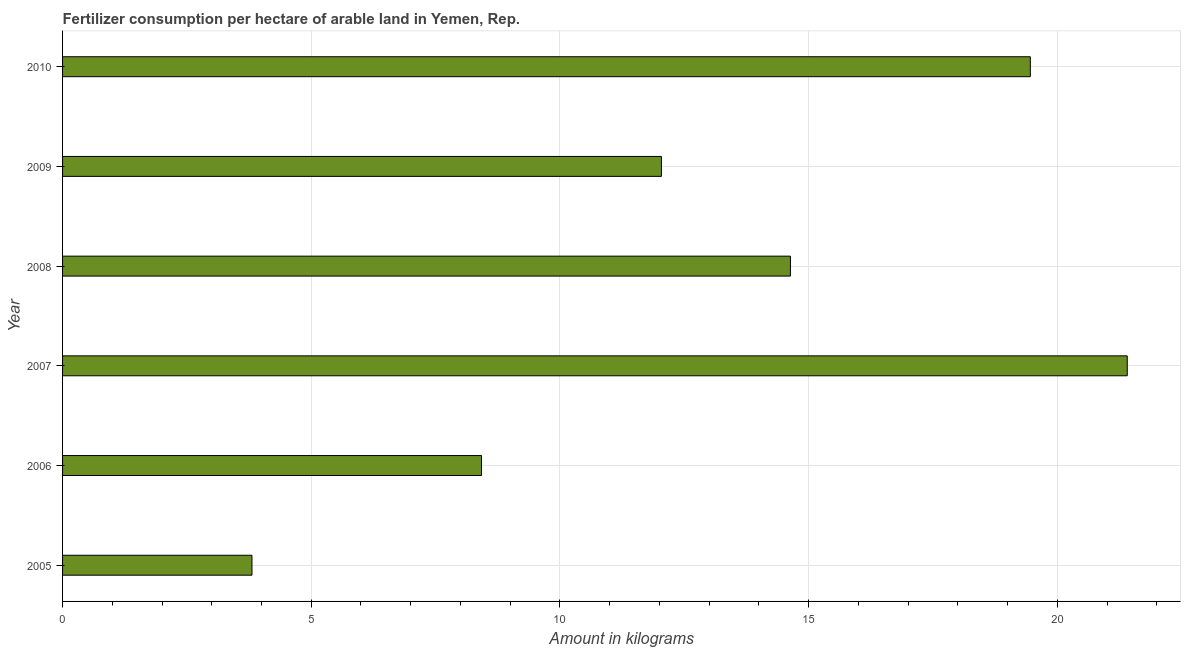Does the graph contain any zero values?
Provide a succinct answer. No. What is the title of the graph?
Ensure brevity in your answer.  Fertilizer consumption per hectare of arable land in Yemen, Rep. . What is the label or title of the X-axis?
Keep it short and to the point. Amount in kilograms. What is the amount of fertilizer consumption in 2007?
Keep it short and to the point. 21.41. Across all years, what is the maximum amount of fertilizer consumption?
Offer a very short reply. 21.41. Across all years, what is the minimum amount of fertilizer consumption?
Your answer should be compact. 3.81. What is the sum of the amount of fertilizer consumption?
Make the answer very short. 79.77. What is the difference between the amount of fertilizer consumption in 2006 and 2007?
Offer a very short reply. -12.98. What is the average amount of fertilizer consumption per year?
Your answer should be compact. 13.29. What is the median amount of fertilizer consumption?
Ensure brevity in your answer.  13.34. What is the ratio of the amount of fertilizer consumption in 2005 to that in 2007?
Offer a terse response. 0.18. Is the difference between the amount of fertilizer consumption in 2006 and 2010 greater than the difference between any two years?
Give a very brief answer. No. What is the difference between the highest and the second highest amount of fertilizer consumption?
Offer a very short reply. 1.95. In how many years, is the amount of fertilizer consumption greater than the average amount of fertilizer consumption taken over all years?
Provide a short and direct response. 3. How many bars are there?
Offer a very short reply. 6. What is the difference between two consecutive major ticks on the X-axis?
Provide a succinct answer. 5. What is the Amount in kilograms in 2005?
Provide a succinct answer. 3.81. What is the Amount in kilograms of 2006?
Make the answer very short. 8.42. What is the Amount in kilograms in 2007?
Your answer should be compact. 21.41. What is the Amount in kilograms in 2008?
Make the answer very short. 14.63. What is the Amount in kilograms in 2009?
Ensure brevity in your answer.  12.04. What is the Amount in kilograms of 2010?
Your response must be concise. 19.46. What is the difference between the Amount in kilograms in 2005 and 2006?
Your answer should be compact. -4.62. What is the difference between the Amount in kilograms in 2005 and 2007?
Provide a succinct answer. -17.6. What is the difference between the Amount in kilograms in 2005 and 2008?
Give a very brief answer. -10.83. What is the difference between the Amount in kilograms in 2005 and 2009?
Ensure brevity in your answer.  -8.23. What is the difference between the Amount in kilograms in 2005 and 2010?
Offer a very short reply. -15.65. What is the difference between the Amount in kilograms in 2006 and 2007?
Provide a succinct answer. -12.98. What is the difference between the Amount in kilograms in 2006 and 2008?
Offer a very short reply. -6.21. What is the difference between the Amount in kilograms in 2006 and 2009?
Offer a very short reply. -3.62. What is the difference between the Amount in kilograms in 2006 and 2010?
Your answer should be very brief. -11.03. What is the difference between the Amount in kilograms in 2007 and 2008?
Your answer should be compact. 6.77. What is the difference between the Amount in kilograms in 2007 and 2009?
Your answer should be compact. 9.37. What is the difference between the Amount in kilograms in 2007 and 2010?
Ensure brevity in your answer.  1.95. What is the difference between the Amount in kilograms in 2008 and 2009?
Provide a succinct answer. 2.59. What is the difference between the Amount in kilograms in 2008 and 2010?
Ensure brevity in your answer.  -4.82. What is the difference between the Amount in kilograms in 2009 and 2010?
Your answer should be compact. -7.42. What is the ratio of the Amount in kilograms in 2005 to that in 2006?
Offer a very short reply. 0.45. What is the ratio of the Amount in kilograms in 2005 to that in 2007?
Provide a short and direct response. 0.18. What is the ratio of the Amount in kilograms in 2005 to that in 2008?
Provide a short and direct response. 0.26. What is the ratio of the Amount in kilograms in 2005 to that in 2009?
Provide a succinct answer. 0.32. What is the ratio of the Amount in kilograms in 2005 to that in 2010?
Provide a succinct answer. 0.2. What is the ratio of the Amount in kilograms in 2006 to that in 2007?
Your response must be concise. 0.39. What is the ratio of the Amount in kilograms in 2006 to that in 2008?
Provide a succinct answer. 0.58. What is the ratio of the Amount in kilograms in 2006 to that in 2010?
Keep it short and to the point. 0.43. What is the ratio of the Amount in kilograms in 2007 to that in 2008?
Provide a short and direct response. 1.46. What is the ratio of the Amount in kilograms in 2007 to that in 2009?
Keep it short and to the point. 1.78. What is the ratio of the Amount in kilograms in 2008 to that in 2009?
Ensure brevity in your answer.  1.22. What is the ratio of the Amount in kilograms in 2008 to that in 2010?
Give a very brief answer. 0.75. What is the ratio of the Amount in kilograms in 2009 to that in 2010?
Your answer should be very brief. 0.62. 